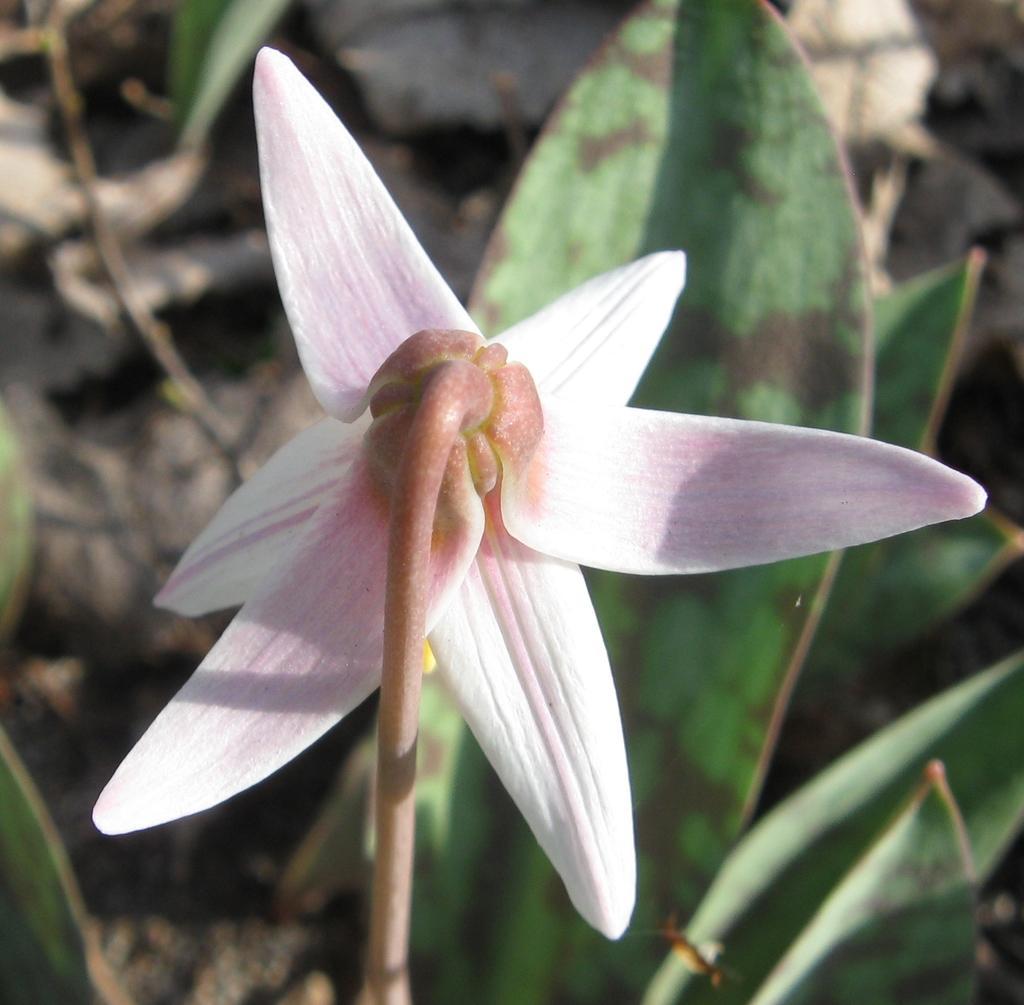In one or two sentences, can you explain what this image depicts? In the image we can see a flower, white and light pink in color. This is a stem of the flower and the leaves. 